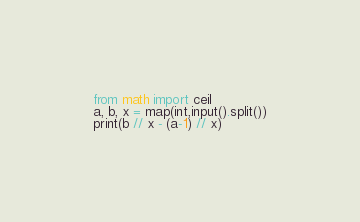Convert code to text. <code><loc_0><loc_0><loc_500><loc_500><_Python_>from math import ceil
a, b, x = map(int,input().split())
print(b // x - (a-1) // x)
</code> 